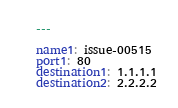<code> <loc_0><loc_0><loc_500><loc_500><_YAML_>---

name1: issue-00515
port1: 80
destination1: 1.1.1.1
destination2: 2.2.2.2
</code> 